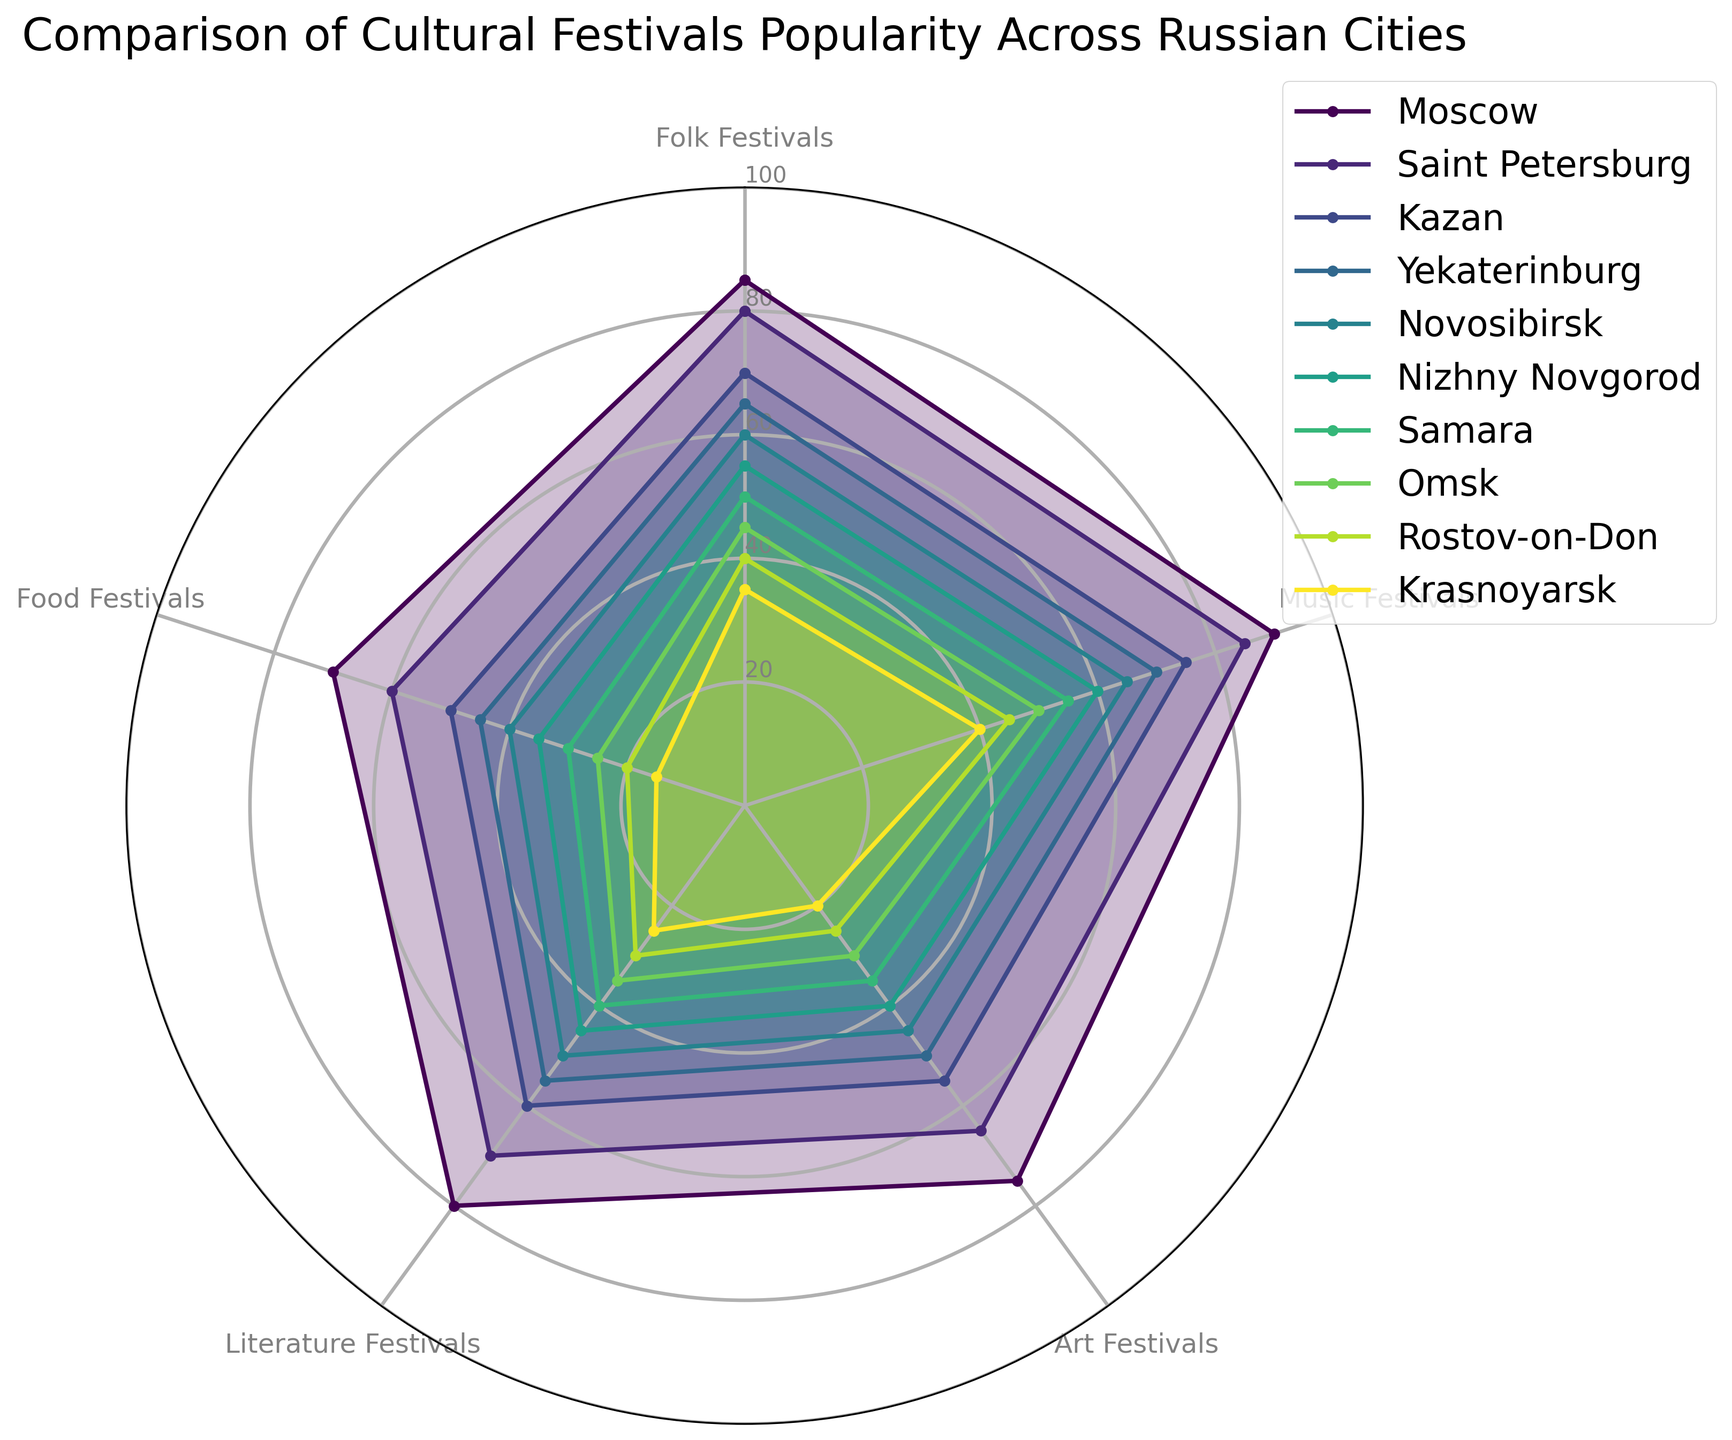Which city has the highest popularity for music festivals? By looking at the radar chart, we can see that Moscow has the highest value for music festivals at 90.
Answer: Moscow Between Kazan and Yekaterinburg, which city has a higher average popularity for all types of festivals? First, calculate the average for Kazan: (70+75+55+60+50)/5 = 62. Then, calculate the average for Yekaterinburg: (65+70+50+55+45)/5 = 57. Kazan has a higher average.
Answer: Kazan What is the difference in popularity of folk festivals between the most popular and least popular cities? The most popular is Moscow at 85 and the least popular is Krasnoyarsk at 35. The difference is 85 - 35 = 50.
Answer: 50 Which city has the least popularity for art festivals, and what is its value? By visually inspecting the art festivals axis, Krasnoyarsk has the least popularity at 20.
Answer: Krasnoyarsk, 20 How does the popularity of literature festivals in Saint Petersburg compare to that in Novosibirsk? Saint Petersburg has a popularity value of 70 while Novosibirsk has 50. Saint Petersburg has a higher popularity by 20 points.
Answer: Saint Petersburg is higher by 20 points What is the most balanced city in terms of having similar values across all festival types? The most balanced city would have radar chart values that form a more regular shape and closely positioned values. A closer look reveals that Moscow, with values 85, 90, 75, 80, 70, appears most balanced.
Answer: Moscow Which two cities show the greatest variance in their popularity for different types of festivals? By visual inspection, Krasnoyarsk and Moscow show the largest variance. Moscow peaks around 85-90 for some festivals while Krasnoyarsk has values mostly ranging from 15-40.
Answer: Moscow and Krasnoyarsk Between Nizhny Novgorod and Samara, which city has lower popularity for food festivals? Nizhny Novgorod has a value of 35 and Samara has 30. Samara has the lower value.
Answer: Samara 